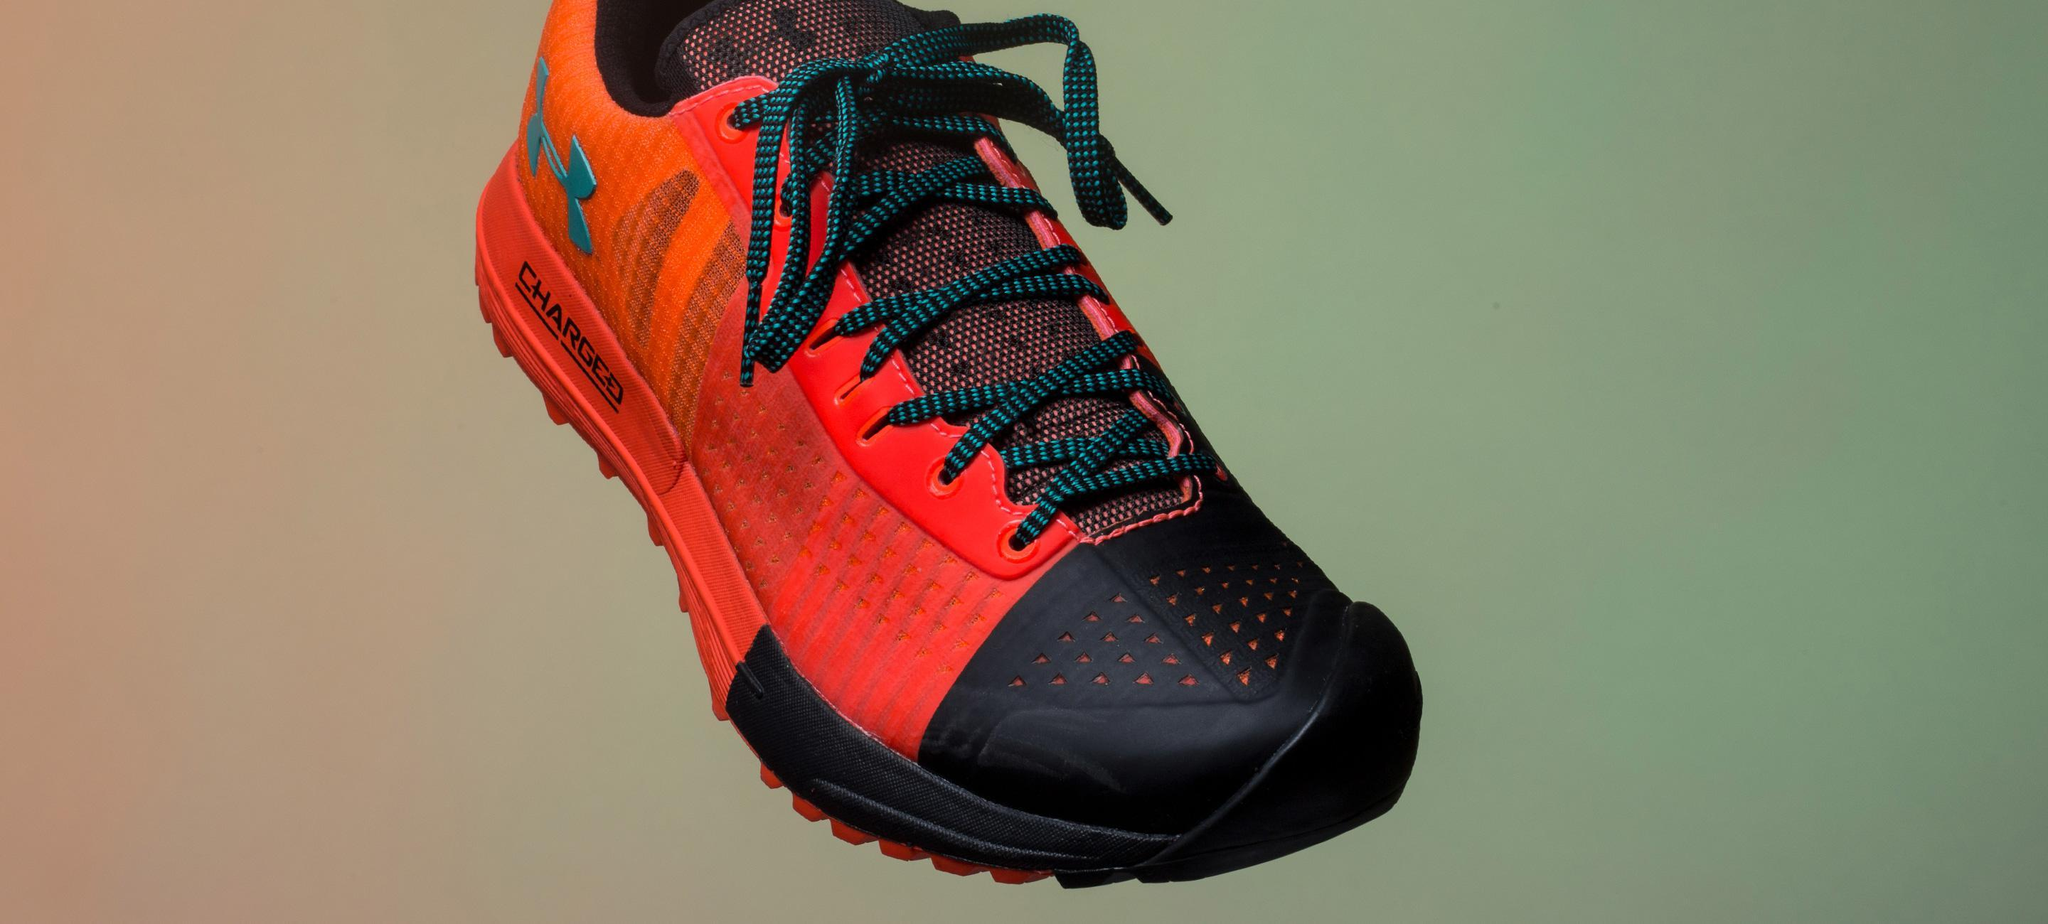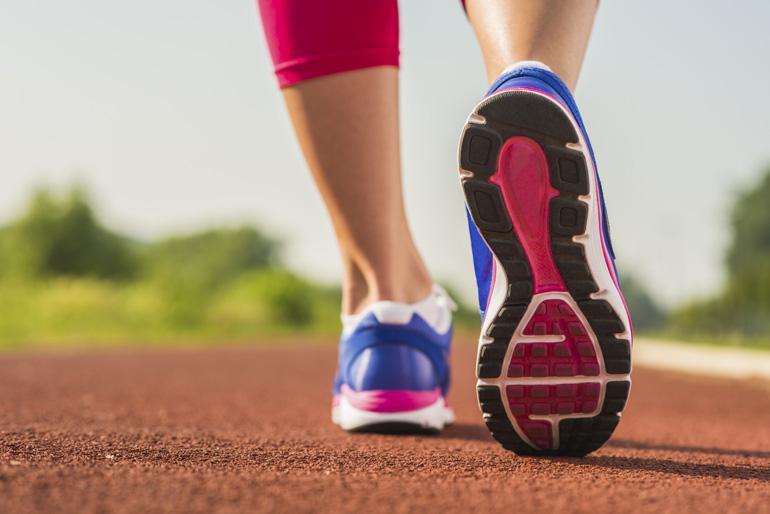The first image is the image on the left, the second image is the image on the right. For the images shown, is this caption "There is a running show with a yellow sole facing up." true? Answer yes or no. No. 